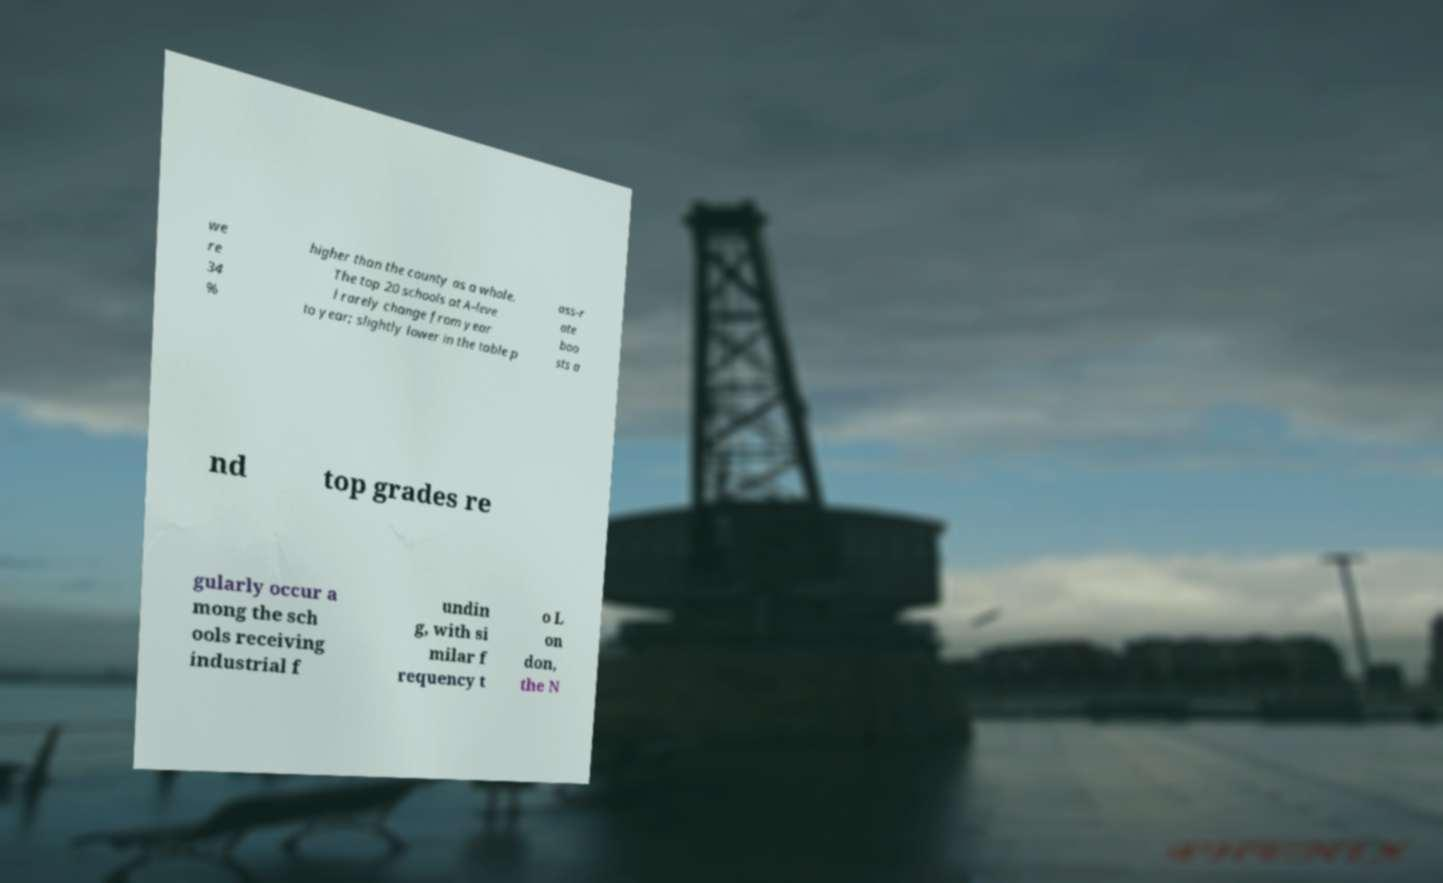Please read and relay the text visible in this image. What does it say? we re 34 % higher than the county as a whole. The top 20 schools at A-leve l rarely change from year to year; slightly lower in the table p ass-r ate boo sts a nd top grades re gularly occur a mong the sch ools receiving industrial f undin g, with si milar f requency t o L on don, the N 